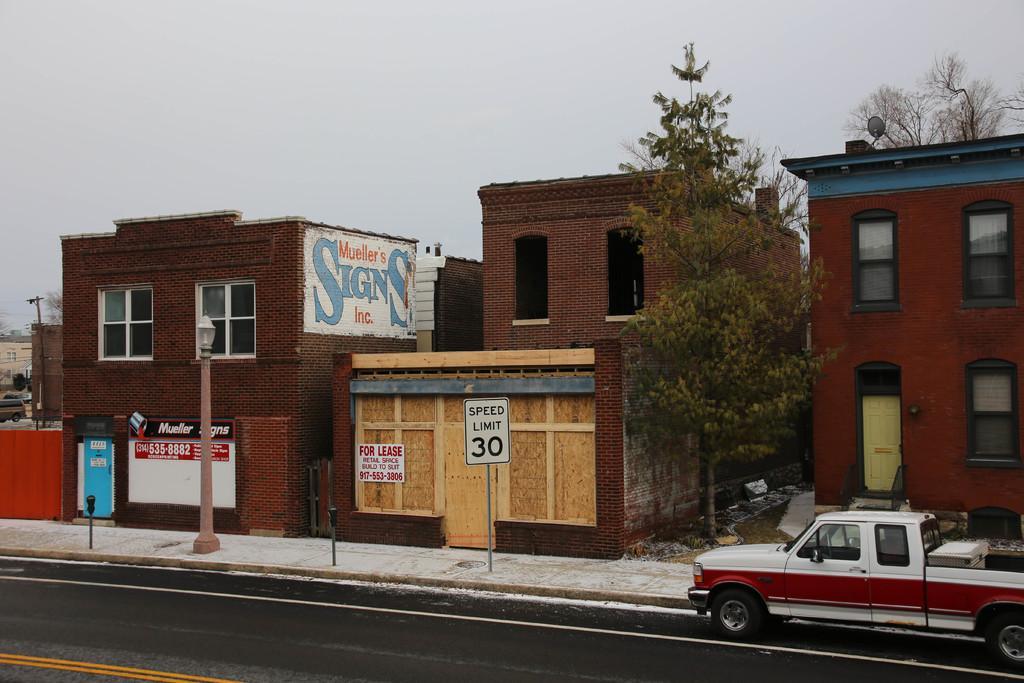Describe this image in one or two sentences. In this picture I can see buildings, trees and I can see a caution board to the pole on the sidewalk and I can see pole lights and I can see a mini truck and a cloudy sky and I can see painting on the wall. 